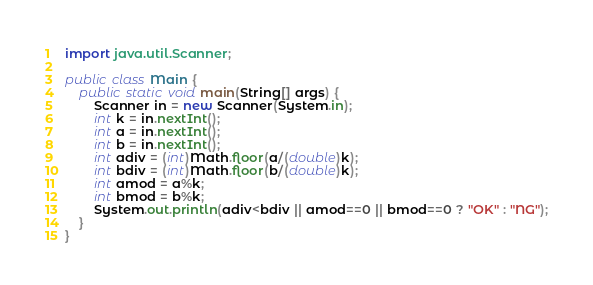<code> <loc_0><loc_0><loc_500><loc_500><_Java_>import java.util.Scanner;

public class Main {
    public static void main(String[] args) {
        Scanner in = new Scanner(System.in);
        int k = in.nextInt();
        int a = in.nextInt();
        int b = in.nextInt();
        int adiv = (int)Math.floor(a/(double)k);
        int bdiv = (int)Math.floor(b/(double)k);
        int amod = a%k;
        int bmod = b%k;
        System.out.println(adiv<bdiv || amod==0 || bmod==0 ? "OK" : "NG");
    }
}
</code> 